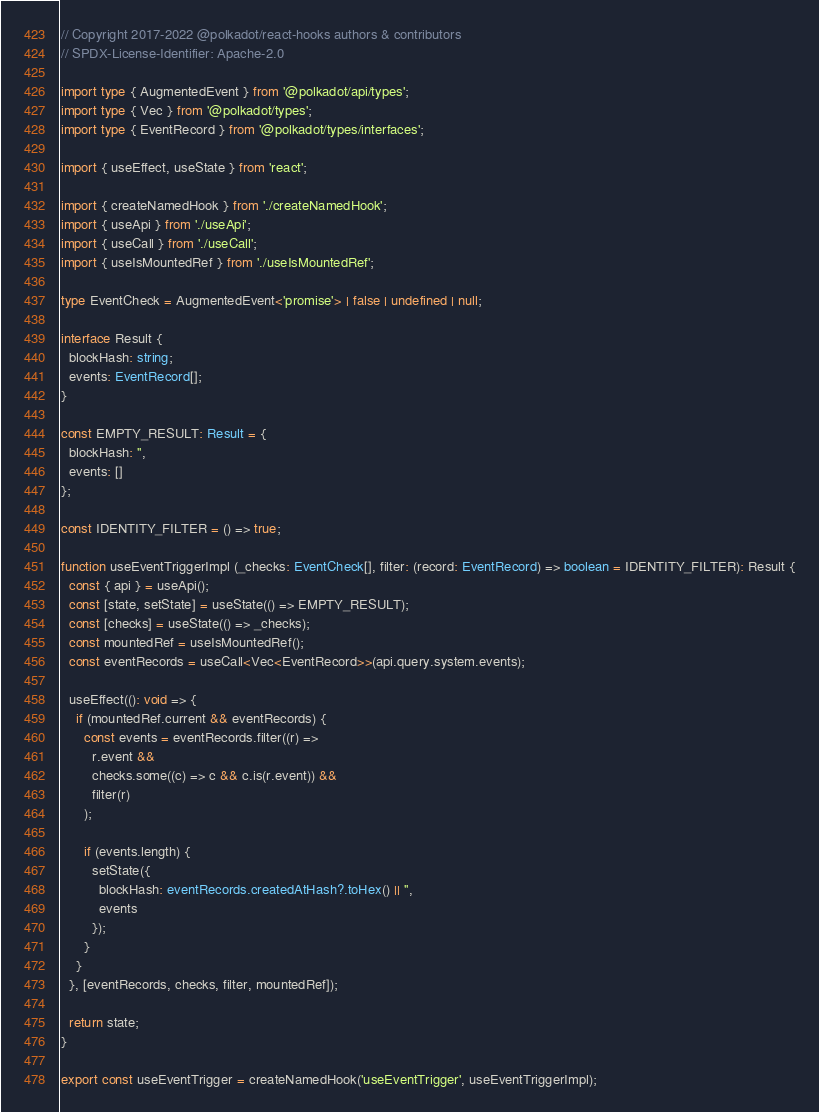<code> <loc_0><loc_0><loc_500><loc_500><_TypeScript_>// Copyright 2017-2022 @polkadot/react-hooks authors & contributors
// SPDX-License-Identifier: Apache-2.0

import type { AugmentedEvent } from '@polkadot/api/types';
import type { Vec } from '@polkadot/types';
import type { EventRecord } from '@polkadot/types/interfaces';

import { useEffect, useState } from 'react';

import { createNamedHook } from './createNamedHook';
import { useApi } from './useApi';
import { useCall } from './useCall';
import { useIsMountedRef } from './useIsMountedRef';

type EventCheck = AugmentedEvent<'promise'> | false | undefined | null;

interface Result {
  blockHash: string;
  events: EventRecord[];
}

const EMPTY_RESULT: Result = {
  blockHash: '',
  events: []
};

const IDENTITY_FILTER = () => true;

function useEventTriggerImpl (_checks: EventCheck[], filter: (record: EventRecord) => boolean = IDENTITY_FILTER): Result {
  const { api } = useApi();
  const [state, setState] = useState(() => EMPTY_RESULT);
  const [checks] = useState(() => _checks);
  const mountedRef = useIsMountedRef();
  const eventRecords = useCall<Vec<EventRecord>>(api.query.system.events);

  useEffect((): void => {
    if (mountedRef.current && eventRecords) {
      const events = eventRecords.filter((r) =>
        r.event &&
        checks.some((c) => c && c.is(r.event)) &&
        filter(r)
      );

      if (events.length) {
        setState({
          blockHash: eventRecords.createdAtHash?.toHex() || '',
          events
        });
      }
    }
  }, [eventRecords, checks, filter, mountedRef]);

  return state;
}

export const useEventTrigger = createNamedHook('useEventTrigger', useEventTriggerImpl);
</code> 